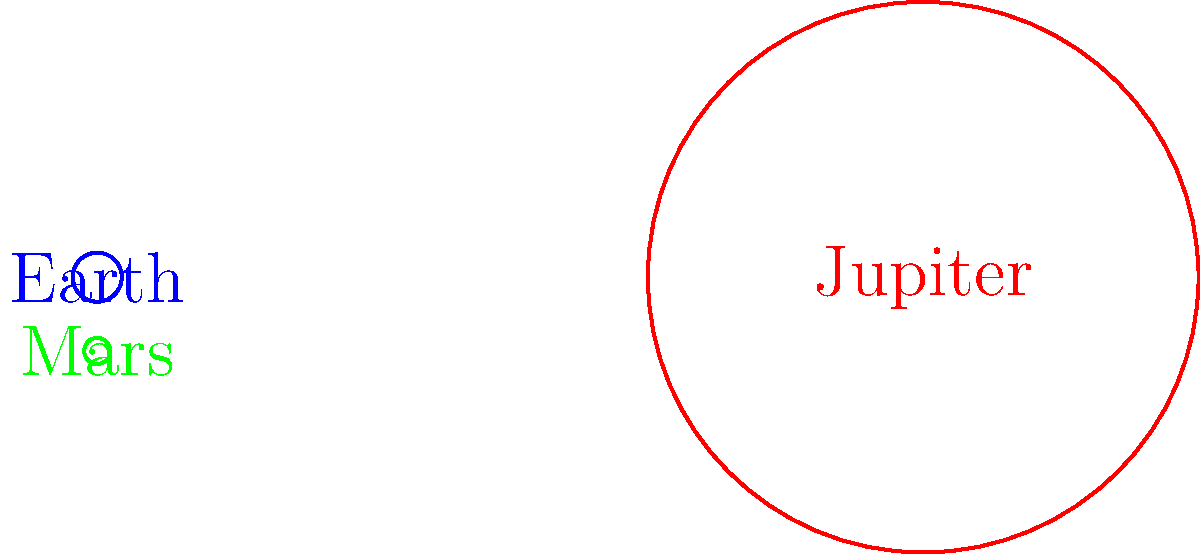In the diagram above, three planets are represented by circles drawn to scale. If the blue circle represents Earth, identify the planets represented by the red and green circles, and explain how their sizes compare to Earth's. To answer this question, let's analyze the relative sizes of the circles:

1. The blue circle represents Earth, which we'll use as our reference.

2. The red circle is much larger than Earth:
   - Its radius is approximately 11.2 times that of Earth.
   - This large size difference indicates that it represents Jupiter, the largest planet in our solar system.

3. The green circle is smaller than Earth:
   - Its radius is about 0.53 times that of Earth.
   - This smaller size suggests it represents Mars, which is known to be smaller than Earth.

4. To compare their sizes:
   - Jupiter (red) has a radius about 11.2 times larger than Earth's.
   - Mars (green) has a radius about 0.53 times (or roughly half) that of Earth's.

5. In terms of volume:
   - Jupiter's volume is about $11.2^3 \approx 1,400$ times that of Earth.
   - Mars' volume is about $0.53^3 \approx 0.15$ times that of Earth.

This comparison demonstrates the vast size differences between planets in our solar system, which is crucial for understanding planetary formation and evolution in astronomy.
Answer: Red: Jupiter (11.2 times Earth's radius), Green: Mars (0.53 times Earth's radius) 